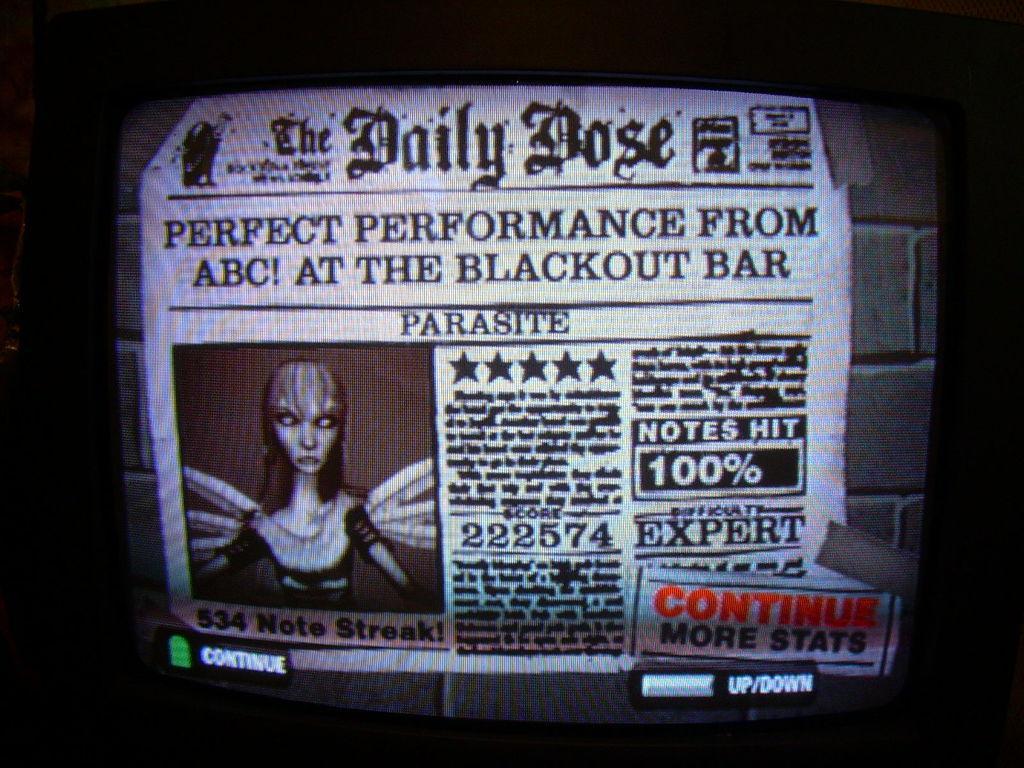How would you summarize this image in a sentence or two? In this image, I can see a television screen. On the screen, there is a newspaper with the words, numbers and a cartoon image. This newspaper is attached to the wall. 